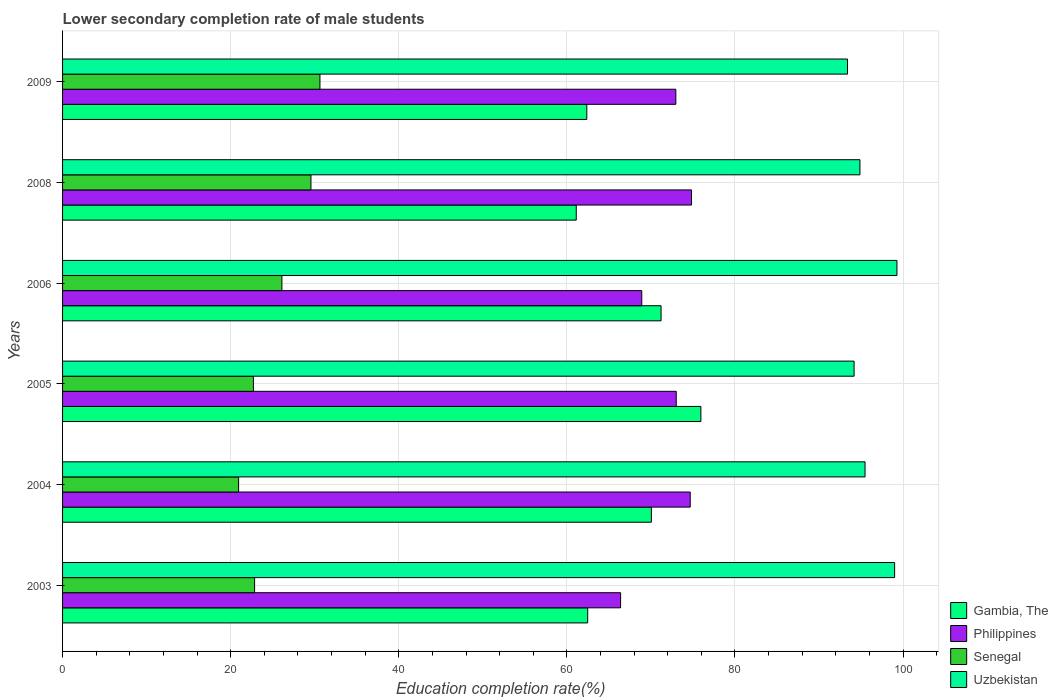How many groups of bars are there?
Give a very brief answer. 6. How many bars are there on the 3rd tick from the top?
Your answer should be very brief. 4. How many bars are there on the 2nd tick from the bottom?
Ensure brevity in your answer.  4. In how many cases, is the number of bars for a given year not equal to the number of legend labels?
Ensure brevity in your answer.  0. What is the lower secondary completion rate of male students in Uzbekistan in 2005?
Offer a very short reply. 94.18. Across all years, what is the maximum lower secondary completion rate of male students in Gambia, The?
Keep it short and to the point. 75.95. Across all years, what is the minimum lower secondary completion rate of male students in Gambia, The?
Provide a succinct answer. 61.12. In which year was the lower secondary completion rate of male students in Gambia, The maximum?
Ensure brevity in your answer.  2005. What is the total lower secondary completion rate of male students in Philippines in the graph?
Provide a succinct answer. 430.8. What is the difference between the lower secondary completion rate of male students in Uzbekistan in 2005 and that in 2006?
Provide a short and direct response. -5.1. What is the difference between the lower secondary completion rate of male students in Philippines in 2004 and the lower secondary completion rate of male students in Uzbekistan in 2009?
Your response must be concise. -18.71. What is the average lower secondary completion rate of male students in Philippines per year?
Provide a succinct answer. 71.8. In the year 2004, what is the difference between the lower secondary completion rate of male students in Senegal and lower secondary completion rate of male students in Gambia, The?
Your response must be concise. -49.11. In how many years, is the lower secondary completion rate of male students in Senegal greater than 32 %?
Your answer should be very brief. 0. What is the ratio of the lower secondary completion rate of male students in Gambia, The in 2003 to that in 2005?
Offer a terse response. 0.82. Is the lower secondary completion rate of male students in Gambia, The in 2004 less than that in 2009?
Ensure brevity in your answer.  No. Is the difference between the lower secondary completion rate of male students in Senegal in 2004 and 2005 greater than the difference between the lower secondary completion rate of male students in Gambia, The in 2004 and 2005?
Provide a short and direct response. Yes. What is the difference between the highest and the second highest lower secondary completion rate of male students in Senegal?
Give a very brief answer. 1.07. What is the difference between the highest and the lowest lower secondary completion rate of male students in Senegal?
Your answer should be compact. 9.68. In how many years, is the lower secondary completion rate of male students in Senegal greater than the average lower secondary completion rate of male students in Senegal taken over all years?
Give a very brief answer. 3. Is it the case that in every year, the sum of the lower secondary completion rate of male students in Senegal and lower secondary completion rate of male students in Uzbekistan is greater than the sum of lower secondary completion rate of male students in Philippines and lower secondary completion rate of male students in Gambia, The?
Provide a succinct answer. No. What does the 1st bar from the top in 2005 represents?
Make the answer very short. Uzbekistan. What does the 4th bar from the bottom in 2006 represents?
Keep it short and to the point. Uzbekistan. Is it the case that in every year, the sum of the lower secondary completion rate of male students in Uzbekistan and lower secondary completion rate of male students in Gambia, The is greater than the lower secondary completion rate of male students in Philippines?
Your answer should be compact. Yes. How many years are there in the graph?
Your answer should be compact. 6. How many legend labels are there?
Provide a short and direct response. 4. What is the title of the graph?
Your answer should be compact. Lower secondary completion rate of male students. What is the label or title of the X-axis?
Offer a terse response. Education completion rate(%). What is the Education completion rate(%) in Gambia, The in 2003?
Your response must be concise. 62.48. What is the Education completion rate(%) in Philippines in 2003?
Keep it short and to the point. 66.39. What is the Education completion rate(%) in Senegal in 2003?
Your answer should be compact. 22.85. What is the Education completion rate(%) in Uzbekistan in 2003?
Offer a terse response. 99. What is the Education completion rate(%) in Gambia, The in 2004?
Offer a very short reply. 70.06. What is the Education completion rate(%) of Philippines in 2004?
Offer a terse response. 74.68. What is the Education completion rate(%) of Senegal in 2004?
Keep it short and to the point. 20.95. What is the Education completion rate(%) of Uzbekistan in 2004?
Ensure brevity in your answer.  95.48. What is the Education completion rate(%) of Gambia, The in 2005?
Provide a succinct answer. 75.95. What is the Education completion rate(%) of Philippines in 2005?
Your response must be concise. 73.02. What is the Education completion rate(%) in Senegal in 2005?
Offer a very short reply. 22.7. What is the Education completion rate(%) in Uzbekistan in 2005?
Give a very brief answer. 94.18. What is the Education completion rate(%) of Gambia, The in 2006?
Your answer should be compact. 71.21. What is the Education completion rate(%) of Philippines in 2006?
Give a very brief answer. 68.91. What is the Education completion rate(%) in Senegal in 2006?
Your answer should be compact. 26.09. What is the Education completion rate(%) of Uzbekistan in 2006?
Provide a succinct answer. 99.27. What is the Education completion rate(%) in Gambia, The in 2008?
Provide a succinct answer. 61.12. What is the Education completion rate(%) of Philippines in 2008?
Provide a succinct answer. 74.83. What is the Education completion rate(%) in Senegal in 2008?
Your answer should be compact. 29.55. What is the Education completion rate(%) of Uzbekistan in 2008?
Your response must be concise. 94.87. What is the Education completion rate(%) in Gambia, The in 2009?
Your answer should be very brief. 62.38. What is the Education completion rate(%) of Philippines in 2009?
Your answer should be compact. 72.97. What is the Education completion rate(%) of Senegal in 2009?
Ensure brevity in your answer.  30.62. What is the Education completion rate(%) in Uzbekistan in 2009?
Your answer should be very brief. 93.39. Across all years, what is the maximum Education completion rate(%) in Gambia, The?
Keep it short and to the point. 75.95. Across all years, what is the maximum Education completion rate(%) in Philippines?
Your answer should be compact. 74.83. Across all years, what is the maximum Education completion rate(%) of Senegal?
Ensure brevity in your answer.  30.62. Across all years, what is the maximum Education completion rate(%) in Uzbekistan?
Offer a very short reply. 99.27. Across all years, what is the minimum Education completion rate(%) in Gambia, The?
Provide a short and direct response. 61.12. Across all years, what is the minimum Education completion rate(%) in Philippines?
Your response must be concise. 66.39. Across all years, what is the minimum Education completion rate(%) of Senegal?
Provide a succinct answer. 20.95. Across all years, what is the minimum Education completion rate(%) in Uzbekistan?
Provide a short and direct response. 93.39. What is the total Education completion rate(%) of Gambia, The in the graph?
Offer a terse response. 403.19. What is the total Education completion rate(%) in Philippines in the graph?
Make the answer very short. 430.8. What is the total Education completion rate(%) in Senegal in the graph?
Make the answer very short. 152.77. What is the total Education completion rate(%) in Uzbekistan in the graph?
Provide a short and direct response. 576.19. What is the difference between the Education completion rate(%) in Gambia, The in 2003 and that in 2004?
Give a very brief answer. -7.58. What is the difference between the Education completion rate(%) in Philippines in 2003 and that in 2004?
Ensure brevity in your answer.  -8.28. What is the difference between the Education completion rate(%) in Senegal in 2003 and that in 2004?
Offer a terse response. 1.9. What is the difference between the Education completion rate(%) in Uzbekistan in 2003 and that in 2004?
Offer a terse response. 3.52. What is the difference between the Education completion rate(%) in Gambia, The in 2003 and that in 2005?
Offer a terse response. -13.47. What is the difference between the Education completion rate(%) of Philippines in 2003 and that in 2005?
Your answer should be very brief. -6.62. What is the difference between the Education completion rate(%) of Senegal in 2003 and that in 2005?
Offer a terse response. 0.14. What is the difference between the Education completion rate(%) in Uzbekistan in 2003 and that in 2005?
Provide a succinct answer. 4.82. What is the difference between the Education completion rate(%) in Gambia, The in 2003 and that in 2006?
Provide a short and direct response. -8.73. What is the difference between the Education completion rate(%) in Philippines in 2003 and that in 2006?
Your answer should be compact. -2.52. What is the difference between the Education completion rate(%) in Senegal in 2003 and that in 2006?
Make the answer very short. -3.25. What is the difference between the Education completion rate(%) of Uzbekistan in 2003 and that in 2006?
Your answer should be very brief. -0.28. What is the difference between the Education completion rate(%) of Gambia, The in 2003 and that in 2008?
Provide a short and direct response. 1.36. What is the difference between the Education completion rate(%) of Philippines in 2003 and that in 2008?
Your answer should be very brief. -8.44. What is the difference between the Education completion rate(%) in Senegal in 2003 and that in 2008?
Give a very brief answer. -6.71. What is the difference between the Education completion rate(%) in Uzbekistan in 2003 and that in 2008?
Offer a very short reply. 4.13. What is the difference between the Education completion rate(%) of Gambia, The in 2003 and that in 2009?
Offer a terse response. 0.1. What is the difference between the Education completion rate(%) of Philippines in 2003 and that in 2009?
Keep it short and to the point. -6.57. What is the difference between the Education completion rate(%) of Senegal in 2003 and that in 2009?
Keep it short and to the point. -7.78. What is the difference between the Education completion rate(%) in Uzbekistan in 2003 and that in 2009?
Your answer should be very brief. 5.61. What is the difference between the Education completion rate(%) in Gambia, The in 2004 and that in 2005?
Offer a terse response. -5.89. What is the difference between the Education completion rate(%) of Philippines in 2004 and that in 2005?
Give a very brief answer. 1.66. What is the difference between the Education completion rate(%) of Senegal in 2004 and that in 2005?
Your response must be concise. -1.76. What is the difference between the Education completion rate(%) of Uzbekistan in 2004 and that in 2005?
Offer a terse response. 1.3. What is the difference between the Education completion rate(%) in Gambia, The in 2004 and that in 2006?
Your answer should be very brief. -1.15. What is the difference between the Education completion rate(%) of Philippines in 2004 and that in 2006?
Your response must be concise. 5.77. What is the difference between the Education completion rate(%) in Senegal in 2004 and that in 2006?
Give a very brief answer. -5.15. What is the difference between the Education completion rate(%) in Uzbekistan in 2004 and that in 2006?
Provide a succinct answer. -3.79. What is the difference between the Education completion rate(%) of Gambia, The in 2004 and that in 2008?
Your response must be concise. 8.94. What is the difference between the Education completion rate(%) in Philippines in 2004 and that in 2008?
Keep it short and to the point. -0.16. What is the difference between the Education completion rate(%) in Senegal in 2004 and that in 2008?
Ensure brevity in your answer.  -8.61. What is the difference between the Education completion rate(%) of Uzbekistan in 2004 and that in 2008?
Provide a succinct answer. 0.61. What is the difference between the Education completion rate(%) in Gambia, The in 2004 and that in 2009?
Your answer should be very brief. 7.68. What is the difference between the Education completion rate(%) in Philippines in 2004 and that in 2009?
Offer a terse response. 1.71. What is the difference between the Education completion rate(%) in Senegal in 2004 and that in 2009?
Your answer should be compact. -9.68. What is the difference between the Education completion rate(%) in Uzbekistan in 2004 and that in 2009?
Offer a terse response. 2.09. What is the difference between the Education completion rate(%) in Gambia, The in 2005 and that in 2006?
Give a very brief answer. 4.74. What is the difference between the Education completion rate(%) of Philippines in 2005 and that in 2006?
Offer a very short reply. 4.1. What is the difference between the Education completion rate(%) in Senegal in 2005 and that in 2006?
Offer a very short reply. -3.39. What is the difference between the Education completion rate(%) of Uzbekistan in 2005 and that in 2006?
Provide a short and direct response. -5.1. What is the difference between the Education completion rate(%) of Gambia, The in 2005 and that in 2008?
Offer a very short reply. 14.83. What is the difference between the Education completion rate(%) in Philippines in 2005 and that in 2008?
Give a very brief answer. -1.82. What is the difference between the Education completion rate(%) in Senegal in 2005 and that in 2008?
Keep it short and to the point. -6.85. What is the difference between the Education completion rate(%) of Uzbekistan in 2005 and that in 2008?
Your answer should be very brief. -0.7. What is the difference between the Education completion rate(%) of Gambia, The in 2005 and that in 2009?
Offer a terse response. 13.57. What is the difference between the Education completion rate(%) in Philippines in 2005 and that in 2009?
Provide a succinct answer. 0.05. What is the difference between the Education completion rate(%) of Senegal in 2005 and that in 2009?
Make the answer very short. -7.92. What is the difference between the Education completion rate(%) of Uzbekistan in 2005 and that in 2009?
Your answer should be compact. 0.78. What is the difference between the Education completion rate(%) in Gambia, The in 2006 and that in 2008?
Give a very brief answer. 10.09. What is the difference between the Education completion rate(%) in Philippines in 2006 and that in 2008?
Make the answer very short. -5.92. What is the difference between the Education completion rate(%) of Senegal in 2006 and that in 2008?
Provide a short and direct response. -3.46. What is the difference between the Education completion rate(%) in Uzbekistan in 2006 and that in 2008?
Give a very brief answer. 4.4. What is the difference between the Education completion rate(%) in Gambia, The in 2006 and that in 2009?
Your response must be concise. 8.83. What is the difference between the Education completion rate(%) of Philippines in 2006 and that in 2009?
Make the answer very short. -4.05. What is the difference between the Education completion rate(%) in Senegal in 2006 and that in 2009?
Provide a succinct answer. -4.53. What is the difference between the Education completion rate(%) of Uzbekistan in 2006 and that in 2009?
Give a very brief answer. 5.88. What is the difference between the Education completion rate(%) in Gambia, The in 2008 and that in 2009?
Offer a very short reply. -1.26. What is the difference between the Education completion rate(%) of Philippines in 2008 and that in 2009?
Keep it short and to the point. 1.87. What is the difference between the Education completion rate(%) in Senegal in 2008 and that in 2009?
Offer a very short reply. -1.07. What is the difference between the Education completion rate(%) of Uzbekistan in 2008 and that in 2009?
Offer a very short reply. 1.48. What is the difference between the Education completion rate(%) in Gambia, The in 2003 and the Education completion rate(%) in Philippines in 2004?
Provide a succinct answer. -12.2. What is the difference between the Education completion rate(%) of Gambia, The in 2003 and the Education completion rate(%) of Senegal in 2004?
Your answer should be very brief. 41.53. What is the difference between the Education completion rate(%) in Gambia, The in 2003 and the Education completion rate(%) in Uzbekistan in 2004?
Your response must be concise. -33. What is the difference between the Education completion rate(%) in Philippines in 2003 and the Education completion rate(%) in Senegal in 2004?
Offer a terse response. 45.45. What is the difference between the Education completion rate(%) in Philippines in 2003 and the Education completion rate(%) in Uzbekistan in 2004?
Your answer should be very brief. -29.09. What is the difference between the Education completion rate(%) of Senegal in 2003 and the Education completion rate(%) of Uzbekistan in 2004?
Your answer should be very brief. -72.63. What is the difference between the Education completion rate(%) of Gambia, The in 2003 and the Education completion rate(%) of Philippines in 2005?
Your answer should be very brief. -10.54. What is the difference between the Education completion rate(%) in Gambia, The in 2003 and the Education completion rate(%) in Senegal in 2005?
Your answer should be compact. 39.77. What is the difference between the Education completion rate(%) of Gambia, The in 2003 and the Education completion rate(%) of Uzbekistan in 2005?
Provide a succinct answer. -31.7. What is the difference between the Education completion rate(%) of Philippines in 2003 and the Education completion rate(%) of Senegal in 2005?
Your answer should be compact. 43.69. What is the difference between the Education completion rate(%) in Philippines in 2003 and the Education completion rate(%) in Uzbekistan in 2005?
Ensure brevity in your answer.  -27.78. What is the difference between the Education completion rate(%) in Senegal in 2003 and the Education completion rate(%) in Uzbekistan in 2005?
Your answer should be very brief. -71.33. What is the difference between the Education completion rate(%) of Gambia, The in 2003 and the Education completion rate(%) of Philippines in 2006?
Provide a succinct answer. -6.43. What is the difference between the Education completion rate(%) of Gambia, The in 2003 and the Education completion rate(%) of Senegal in 2006?
Your answer should be compact. 36.38. What is the difference between the Education completion rate(%) of Gambia, The in 2003 and the Education completion rate(%) of Uzbekistan in 2006?
Provide a succinct answer. -36.8. What is the difference between the Education completion rate(%) in Philippines in 2003 and the Education completion rate(%) in Senegal in 2006?
Your answer should be compact. 40.3. What is the difference between the Education completion rate(%) in Philippines in 2003 and the Education completion rate(%) in Uzbekistan in 2006?
Your answer should be compact. -32.88. What is the difference between the Education completion rate(%) of Senegal in 2003 and the Education completion rate(%) of Uzbekistan in 2006?
Your response must be concise. -76.43. What is the difference between the Education completion rate(%) in Gambia, The in 2003 and the Education completion rate(%) in Philippines in 2008?
Keep it short and to the point. -12.36. What is the difference between the Education completion rate(%) in Gambia, The in 2003 and the Education completion rate(%) in Senegal in 2008?
Offer a terse response. 32.93. What is the difference between the Education completion rate(%) of Gambia, The in 2003 and the Education completion rate(%) of Uzbekistan in 2008?
Provide a succinct answer. -32.39. What is the difference between the Education completion rate(%) in Philippines in 2003 and the Education completion rate(%) in Senegal in 2008?
Make the answer very short. 36.84. What is the difference between the Education completion rate(%) of Philippines in 2003 and the Education completion rate(%) of Uzbekistan in 2008?
Offer a very short reply. -28.48. What is the difference between the Education completion rate(%) in Senegal in 2003 and the Education completion rate(%) in Uzbekistan in 2008?
Give a very brief answer. -72.02. What is the difference between the Education completion rate(%) of Gambia, The in 2003 and the Education completion rate(%) of Philippines in 2009?
Make the answer very short. -10.49. What is the difference between the Education completion rate(%) of Gambia, The in 2003 and the Education completion rate(%) of Senegal in 2009?
Offer a terse response. 31.86. What is the difference between the Education completion rate(%) in Gambia, The in 2003 and the Education completion rate(%) in Uzbekistan in 2009?
Offer a very short reply. -30.91. What is the difference between the Education completion rate(%) in Philippines in 2003 and the Education completion rate(%) in Senegal in 2009?
Give a very brief answer. 35.77. What is the difference between the Education completion rate(%) of Philippines in 2003 and the Education completion rate(%) of Uzbekistan in 2009?
Make the answer very short. -27. What is the difference between the Education completion rate(%) of Senegal in 2003 and the Education completion rate(%) of Uzbekistan in 2009?
Offer a very short reply. -70.55. What is the difference between the Education completion rate(%) of Gambia, The in 2004 and the Education completion rate(%) of Philippines in 2005?
Make the answer very short. -2.96. What is the difference between the Education completion rate(%) of Gambia, The in 2004 and the Education completion rate(%) of Senegal in 2005?
Your answer should be compact. 47.35. What is the difference between the Education completion rate(%) of Gambia, The in 2004 and the Education completion rate(%) of Uzbekistan in 2005?
Your answer should be very brief. -24.12. What is the difference between the Education completion rate(%) in Philippines in 2004 and the Education completion rate(%) in Senegal in 2005?
Provide a succinct answer. 51.97. What is the difference between the Education completion rate(%) in Philippines in 2004 and the Education completion rate(%) in Uzbekistan in 2005?
Give a very brief answer. -19.5. What is the difference between the Education completion rate(%) in Senegal in 2004 and the Education completion rate(%) in Uzbekistan in 2005?
Your answer should be very brief. -73.23. What is the difference between the Education completion rate(%) of Gambia, The in 2004 and the Education completion rate(%) of Philippines in 2006?
Make the answer very short. 1.14. What is the difference between the Education completion rate(%) of Gambia, The in 2004 and the Education completion rate(%) of Senegal in 2006?
Give a very brief answer. 43.96. What is the difference between the Education completion rate(%) of Gambia, The in 2004 and the Education completion rate(%) of Uzbekistan in 2006?
Keep it short and to the point. -29.22. What is the difference between the Education completion rate(%) of Philippines in 2004 and the Education completion rate(%) of Senegal in 2006?
Give a very brief answer. 48.58. What is the difference between the Education completion rate(%) in Philippines in 2004 and the Education completion rate(%) in Uzbekistan in 2006?
Your answer should be compact. -24.6. What is the difference between the Education completion rate(%) in Senegal in 2004 and the Education completion rate(%) in Uzbekistan in 2006?
Offer a terse response. -78.33. What is the difference between the Education completion rate(%) in Gambia, The in 2004 and the Education completion rate(%) in Philippines in 2008?
Provide a succinct answer. -4.78. What is the difference between the Education completion rate(%) of Gambia, The in 2004 and the Education completion rate(%) of Senegal in 2008?
Give a very brief answer. 40.5. What is the difference between the Education completion rate(%) of Gambia, The in 2004 and the Education completion rate(%) of Uzbekistan in 2008?
Your answer should be very brief. -24.81. What is the difference between the Education completion rate(%) of Philippines in 2004 and the Education completion rate(%) of Senegal in 2008?
Your answer should be compact. 45.13. What is the difference between the Education completion rate(%) of Philippines in 2004 and the Education completion rate(%) of Uzbekistan in 2008?
Your answer should be compact. -20.19. What is the difference between the Education completion rate(%) in Senegal in 2004 and the Education completion rate(%) in Uzbekistan in 2008?
Your response must be concise. -73.92. What is the difference between the Education completion rate(%) of Gambia, The in 2004 and the Education completion rate(%) of Philippines in 2009?
Your answer should be compact. -2.91. What is the difference between the Education completion rate(%) in Gambia, The in 2004 and the Education completion rate(%) in Senegal in 2009?
Provide a succinct answer. 39.43. What is the difference between the Education completion rate(%) of Gambia, The in 2004 and the Education completion rate(%) of Uzbekistan in 2009?
Provide a succinct answer. -23.34. What is the difference between the Education completion rate(%) of Philippines in 2004 and the Education completion rate(%) of Senegal in 2009?
Ensure brevity in your answer.  44.06. What is the difference between the Education completion rate(%) of Philippines in 2004 and the Education completion rate(%) of Uzbekistan in 2009?
Your answer should be compact. -18.71. What is the difference between the Education completion rate(%) in Senegal in 2004 and the Education completion rate(%) in Uzbekistan in 2009?
Keep it short and to the point. -72.45. What is the difference between the Education completion rate(%) in Gambia, The in 2005 and the Education completion rate(%) in Philippines in 2006?
Offer a terse response. 7.03. What is the difference between the Education completion rate(%) in Gambia, The in 2005 and the Education completion rate(%) in Senegal in 2006?
Keep it short and to the point. 49.85. What is the difference between the Education completion rate(%) of Gambia, The in 2005 and the Education completion rate(%) of Uzbekistan in 2006?
Make the answer very short. -23.33. What is the difference between the Education completion rate(%) of Philippines in 2005 and the Education completion rate(%) of Senegal in 2006?
Provide a succinct answer. 46.92. What is the difference between the Education completion rate(%) in Philippines in 2005 and the Education completion rate(%) in Uzbekistan in 2006?
Make the answer very short. -26.26. What is the difference between the Education completion rate(%) in Senegal in 2005 and the Education completion rate(%) in Uzbekistan in 2006?
Offer a terse response. -76.57. What is the difference between the Education completion rate(%) of Gambia, The in 2005 and the Education completion rate(%) of Philippines in 2008?
Give a very brief answer. 1.11. What is the difference between the Education completion rate(%) of Gambia, The in 2005 and the Education completion rate(%) of Senegal in 2008?
Your answer should be compact. 46.39. What is the difference between the Education completion rate(%) in Gambia, The in 2005 and the Education completion rate(%) in Uzbekistan in 2008?
Offer a terse response. -18.92. What is the difference between the Education completion rate(%) in Philippines in 2005 and the Education completion rate(%) in Senegal in 2008?
Ensure brevity in your answer.  43.46. What is the difference between the Education completion rate(%) of Philippines in 2005 and the Education completion rate(%) of Uzbekistan in 2008?
Provide a short and direct response. -21.85. What is the difference between the Education completion rate(%) in Senegal in 2005 and the Education completion rate(%) in Uzbekistan in 2008?
Your response must be concise. -72.17. What is the difference between the Education completion rate(%) in Gambia, The in 2005 and the Education completion rate(%) in Philippines in 2009?
Offer a terse response. 2.98. What is the difference between the Education completion rate(%) in Gambia, The in 2005 and the Education completion rate(%) in Senegal in 2009?
Offer a very short reply. 45.32. What is the difference between the Education completion rate(%) of Gambia, The in 2005 and the Education completion rate(%) of Uzbekistan in 2009?
Provide a short and direct response. -17.45. What is the difference between the Education completion rate(%) in Philippines in 2005 and the Education completion rate(%) in Senegal in 2009?
Ensure brevity in your answer.  42.39. What is the difference between the Education completion rate(%) in Philippines in 2005 and the Education completion rate(%) in Uzbekistan in 2009?
Make the answer very short. -20.38. What is the difference between the Education completion rate(%) of Senegal in 2005 and the Education completion rate(%) of Uzbekistan in 2009?
Provide a succinct answer. -70.69. What is the difference between the Education completion rate(%) in Gambia, The in 2006 and the Education completion rate(%) in Philippines in 2008?
Offer a terse response. -3.63. What is the difference between the Education completion rate(%) of Gambia, The in 2006 and the Education completion rate(%) of Senegal in 2008?
Provide a short and direct response. 41.66. What is the difference between the Education completion rate(%) in Gambia, The in 2006 and the Education completion rate(%) in Uzbekistan in 2008?
Provide a succinct answer. -23.66. What is the difference between the Education completion rate(%) in Philippines in 2006 and the Education completion rate(%) in Senegal in 2008?
Make the answer very short. 39.36. What is the difference between the Education completion rate(%) in Philippines in 2006 and the Education completion rate(%) in Uzbekistan in 2008?
Make the answer very short. -25.96. What is the difference between the Education completion rate(%) in Senegal in 2006 and the Education completion rate(%) in Uzbekistan in 2008?
Give a very brief answer. -68.78. What is the difference between the Education completion rate(%) in Gambia, The in 2006 and the Education completion rate(%) in Philippines in 2009?
Provide a short and direct response. -1.76. What is the difference between the Education completion rate(%) in Gambia, The in 2006 and the Education completion rate(%) in Senegal in 2009?
Your answer should be compact. 40.59. What is the difference between the Education completion rate(%) of Gambia, The in 2006 and the Education completion rate(%) of Uzbekistan in 2009?
Offer a terse response. -22.18. What is the difference between the Education completion rate(%) of Philippines in 2006 and the Education completion rate(%) of Senegal in 2009?
Offer a very short reply. 38.29. What is the difference between the Education completion rate(%) in Philippines in 2006 and the Education completion rate(%) in Uzbekistan in 2009?
Provide a short and direct response. -24.48. What is the difference between the Education completion rate(%) in Senegal in 2006 and the Education completion rate(%) in Uzbekistan in 2009?
Give a very brief answer. -67.3. What is the difference between the Education completion rate(%) in Gambia, The in 2008 and the Education completion rate(%) in Philippines in 2009?
Provide a short and direct response. -11.85. What is the difference between the Education completion rate(%) of Gambia, The in 2008 and the Education completion rate(%) of Senegal in 2009?
Your answer should be very brief. 30.49. What is the difference between the Education completion rate(%) of Gambia, The in 2008 and the Education completion rate(%) of Uzbekistan in 2009?
Ensure brevity in your answer.  -32.27. What is the difference between the Education completion rate(%) in Philippines in 2008 and the Education completion rate(%) in Senegal in 2009?
Provide a short and direct response. 44.21. What is the difference between the Education completion rate(%) of Philippines in 2008 and the Education completion rate(%) of Uzbekistan in 2009?
Offer a terse response. -18.56. What is the difference between the Education completion rate(%) of Senegal in 2008 and the Education completion rate(%) of Uzbekistan in 2009?
Your answer should be compact. -63.84. What is the average Education completion rate(%) of Gambia, The per year?
Your answer should be very brief. 67.2. What is the average Education completion rate(%) in Philippines per year?
Your response must be concise. 71.8. What is the average Education completion rate(%) in Senegal per year?
Your answer should be very brief. 25.46. What is the average Education completion rate(%) in Uzbekistan per year?
Offer a terse response. 96.03. In the year 2003, what is the difference between the Education completion rate(%) in Gambia, The and Education completion rate(%) in Philippines?
Keep it short and to the point. -3.92. In the year 2003, what is the difference between the Education completion rate(%) in Gambia, The and Education completion rate(%) in Senegal?
Keep it short and to the point. 39.63. In the year 2003, what is the difference between the Education completion rate(%) in Gambia, The and Education completion rate(%) in Uzbekistan?
Your response must be concise. -36.52. In the year 2003, what is the difference between the Education completion rate(%) of Philippines and Education completion rate(%) of Senegal?
Offer a terse response. 43.55. In the year 2003, what is the difference between the Education completion rate(%) of Philippines and Education completion rate(%) of Uzbekistan?
Provide a succinct answer. -32.6. In the year 2003, what is the difference between the Education completion rate(%) of Senegal and Education completion rate(%) of Uzbekistan?
Your answer should be compact. -76.15. In the year 2004, what is the difference between the Education completion rate(%) of Gambia, The and Education completion rate(%) of Philippines?
Provide a short and direct response. -4.62. In the year 2004, what is the difference between the Education completion rate(%) in Gambia, The and Education completion rate(%) in Senegal?
Offer a terse response. 49.11. In the year 2004, what is the difference between the Education completion rate(%) of Gambia, The and Education completion rate(%) of Uzbekistan?
Your response must be concise. -25.42. In the year 2004, what is the difference between the Education completion rate(%) of Philippines and Education completion rate(%) of Senegal?
Give a very brief answer. 53.73. In the year 2004, what is the difference between the Education completion rate(%) in Philippines and Education completion rate(%) in Uzbekistan?
Your response must be concise. -20.8. In the year 2004, what is the difference between the Education completion rate(%) of Senegal and Education completion rate(%) of Uzbekistan?
Give a very brief answer. -74.53. In the year 2005, what is the difference between the Education completion rate(%) in Gambia, The and Education completion rate(%) in Philippines?
Provide a short and direct response. 2.93. In the year 2005, what is the difference between the Education completion rate(%) in Gambia, The and Education completion rate(%) in Senegal?
Make the answer very short. 53.24. In the year 2005, what is the difference between the Education completion rate(%) in Gambia, The and Education completion rate(%) in Uzbekistan?
Provide a short and direct response. -18.23. In the year 2005, what is the difference between the Education completion rate(%) in Philippines and Education completion rate(%) in Senegal?
Offer a terse response. 50.31. In the year 2005, what is the difference between the Education completion rate(%) in Philippines and Education completion rate(%) in Uzbekistan?
Your response must be concise. -21.16. In the year 2005, what is the difference between the Education completion rate(%) in Senegal and Education completion rate(%) in Uzbekistan?
Offer a terse response. -71.47. In the year 2006, what is the difference between the Education completion rate(%) of Gambia, The and Education completion rate(%) of Philippines?
Provide a succinct answer. 2.3. In the year 2006, what is the difference between the Education completion rate(%) of Gambia, The and Education completion rate(%) of Senegal?
Make the answer very short. 45.11. In the year 2006, what is the difference between the Education completion rate(%) of Gambia, The and Education completion rate(%) of Uzbekistan?
Provide a succinct answer. -28.07. In the year 2006, what is the difference between the Education completion rate(%) in Philippines and Education completion rate(%) in Senegal?
Offer a terse response. 42.82. In the year 2006, what is the difference between the Education completion rate(%) in Philippines and Education completion rate(%) in Uzbekistan?
Your answer should be compact. -30.36. In the year 2006, what is the difference between the Education completion rate(%) in Senegal and Education completion rate(%) in Uzbekistan?
Provide a succinct answer. -73.18. In the year 2008, what is the difference between the Education completion rate(%) in Gambia, The and Education completion rate(%) in Philippines?
Offer a terse response. -13.72. In the year 2008, what is the difference between the Education completion rate(%) of Gambia, The and Education completion rate(%) of Senegal?
Ensure brevity in your answer.  31.56. In the year 2008, what is the difference between the Education completion rate(%) of Gambia, The and Education completion rate(%) of Uzbekistan?
Make the answer very short. -33.75. In the year 2008, what is the difference between the Education completion rate(%) in Philippines and Education completion rate(%) in Senegal?
Provide a short and direct response. 45.28. In the year 2008, what is the difference between the Education completion rate(%) in Philippines and Education completion rate(%) in Uzbekistan?
Make the answer very short. -20.04. In the year 2008, what is the difference between the Education completion rate(%) of Senegal and Education completion rate(%) of Uzbekistan?
Your response must be concise. -65.32. In the year 2009, what is the difference between the Education completion rate(%) of Gambia, The and Education completion rate(%) of Philippines?
Keep it short and to the point. -10.59. In the year 2009, what is the difference between the Education completion rate(%) of Gambia, The and Education completion rate(%) of Senegal?
Your answer should be very brief. 31.75. In the year 2009, what is the difference between the Education completion rate(%) of Gambia, The and Education completion rate(%) of Uzbekistan?
Ensure brevity in your answer.  -31.02. In the year 2009, what is the difference between the Education completion rate(%) in Philippines and Education completion rate(%) in Senegal?
Offer a terse response. 42.34. In the year 2009, what is the difference between the Education completion rate(%) of Philippines and Education completion rate(%) of Uzbekistan?
Make the answer very short. -20.43. In the year 2009, what is the difference between the Education completion rate(%) of Senegal and Education completion rate(%) of Uzbekistan?
Ensure brevity in your answer.  -62.77. What is the ratio of the Education completion rate(%) in Gambia, The in 2003 to that in 2004?
Offer a very short reply. 0.89. What is the ratio of the Education completion rate(%) in Philippines in 2003 to that in 2004?
Offer a terse response. 0.89. What is the ratio of the Education completion rate(%) of Senegal in 2003 to that in 2004?
Make the answer very short. 1.09. What is the ratio of the Education completion rate(%) in Uzbekistan in 2003 to that in 2004?
Your response must be concise. 1.04. What is the ratio of the Education completion rate(%) in Gambia, The in 2003 to that in 2005?
Provide a short and direct response. 0.82. What is the ratio of the Education completion rate(%) of Philippines in 2003 to that in 2005?
Your answer should be compact. 0.91. What is the ratio of the Education completion rate(%) of Uzbekistan in 2003 to that in 2005?
Offer a terse response. 1.05. What is the ratio of the Education completion rate(%) of Gambia, The in 2003 to that in 2006?
Provide a short and direct response. 0.88. What is the ratio of the Education completion rate(%) of Philippines in 2003 to that in 2006?
Your answer should be very brief. 0.96. What is the ratio of the Education completion rate(%) of Senegal in 2003 to that in 2006?
Give a very brief answer. 0.88. What is the ratio of the Education completion rate(%) of Gambia, The in 2003 to that in 2008?
Keep it short and to the point. 1.02. What is the ratio of the Education completion rate(%) in Philippines in 2003 to that in 2008?
Keep it short and to the point. 0.89. What is the ratio of the Education completion rate(%) of Senegal in 2003 to that in 2008?
Your answer should be compact. 0.77. What is the ratio of the Education completion rate(%) in Uzbekistan in 2003 to that in 2008?
Ensure brevity in your answer.  1.04. What is the ratio of the Education completion rate(%) of Gambia, The in 2003 to that in 2009?
Your answer should be very brief. 1. What is the ratio of the Education completion rate(%) in Philippines in 2003 to that in 2009?
Offer a terse response. 0.91. What is the ratio of the Education completion rate(%) of Senegal in 2003 to that in 2009?
Offer a very short reply. 0.75. What is the ratio of the Education completion rate(%) of Uzbekistan in 2003 to that in 2009?
Your answer should be compact. 1.06. What is the ratio of the Education completion rate(%) of Gambia, The in 2004 to that in 2005?
Your answer should be compact. 0.92. What is the ratio of the Education completion rate(%) in Philippines in 2004 to that in 2005?
Your answer should be very brief. 1.02. What is the ratio of the Education completion rate(%) of Senegal in 2004 to that in 2005?
Give a very brief answer. 0.92. What is the ratio of the Education completion rate(%) of Uzbekistan in 2004 to that in 2005?
Keep it short and to the point. 1.01. What is the ratio of the Education completion rate(%) of Gambia, The in 2004 to that in 2006?
Provide a succinct answer. 0.98. What is the ratio of the Education completion rate(%) of Philippines in 2004 to that in 2006?
Offer a very short reply. 1.08. What is the ratio of the Education completion rate(%) of Senegal in 2004 to that in 2006?
Give a very brief answer. 0.8. What is the ratio of the Education completion rate(%) in Uzbekistan in 2004 to that in 2006?
Your response must be concise. 0.96. What is the ratio of the Education completion rate(%) of Gambia, The in 2004 to that in 2008?
Provide a short and direct response. 1.15. What is the ratio of the Education completion rate(%) in Senegal in 2004 to that in 2008?
Ensure brevity in your answer.  0.71. What is the ratio of the Education completion rate(%) of Uzbekistan in 2004 to that in 2008?
Provide a succinct answer. 1.01. What is the ratio of the Education completion rate(%) in Gambia, The in 2004 to that in 2009?
Keep it short and to the point. 1.12. What is the ratio of the Education completion rate(%) in Philippines in 2004 to that in 2009?
Your response must be concise. 1.02. What is the ratio of the Education completion rate(%) in Senegal in 2004 to that in 2009?
Offer a terse response. 0.68. What is the ratio of the Education completion rate(%) in Uzbekistan in 2004 to that in 2009?
Ensure brevity in your answer.  1.02. What is the ratio of the Education completion rate(%) in Gambia, The in 2005 to that in 2006?
Make the answer very short. 1.07. What is the ratio of the Education completion rate(%) of Philippines in 2005 to that in 2006?
Offer a terse response. 1.06. What is the ratio of the Education completion rate(%) in Senegal in 2005 to that in 2006?
Offer a terse response. 0.87. What is the ratio of the Education completion rate(%) in Uzbekistan in 2005 to that in 2006?
Make the answer very short. 0.95. What is the ratio of the Education completion rate(%) of Gambia, The in 2005 to that in 2008?
Your answer should be very brief. 1.24. What is the ratio of the Education completion rate(%) of Philippines in 2005 to that in 2008?
Your answer should be very brief. 0.98. What is the ratio of the Education completion rate(%) of Senegal in 2005 to that in 2008?
Your response must be concise. 0.77. What is the ratio of the Education completion rate(%) in Uzbekistan in 2005 to that in 2008?
Your answer should be compact. 0.99. What is the ratio of the Education completion rate(%) in Gambia, The in 2005 to that in 2009?
Make the answer very short. 1.22. What is the ratio of the Education completion rate(%) in Philippines in 2005 to that in 2009?
Offer a very short reply. 1. What is the ratio of the Education completion rate(%) of Senegal in 2005 to that in 2009?
Your response must be concise. 0.74. What is the ratio of the Education completion rate(%) of Uzbekistan in 2005 to that in 2009?
Offer a very short reply. 1.01. What is the ratio of the Education completion rate(%) of Gambia, The in 2006 to that in 2008?
Offer a very short reply. 1.17. What is the ratio of the Education completion rate(%) of Philippines in 2006 to that in 2008?
Your response must be concise. 0.92. What is the ratio of the Education completion rate(%) in Senegal in 2006 to that in 2008?
Your response must be concise. 0.88. What is the ratio of the Education completion rate(%) in Uzbekistan in 2006 to that in 2008?
Give a very brief answer. 1.05. What is the ratio of the Education completion rate(%) in Gambia, The in 2006 to that in 2009?
Make the answer very short. 1.14. What is the ratio of the Education completion rate(%) of Philippines in 2006 to that in 2009?
Offer a terse response. 0.94. What is the ratio of the Education completion rate(%) in Senegal in 2006 to that in 2009?
Your answer should be very brief. 0.85. What is the ratio of the Education completion rate(%) of Uzbekistan in 2006 to that in 2009?
Your response must be concise. 1.06. What is the ratio of the Education completion rate(%) of Gambia, The in 2008 to that in 2009?
Give a very brief answer. 0.98. What is the ratio of the Education completion rate(%) of Philippines in 2008 to that in 2009?
Your answer should be compact. 1.03. What is the ratio of the Education completion rate(%) in Senegal in 2008 to that in 2009?
Offer a terse response. 0.97. What is the ratio of the Education completion rate(%) of Uzbekistan in 2008 to that in 2009?
Provide a succinct answer. 1.02. What is the difference between the highest and the second highest Education completion rate(%) in Gambia, The?
Offer a terse response. 4.74. What is the difference between the highest and the second highest Education completion rate(%) in Philippines?
Provide a succinct answer. 0.16. What is the difference between the highest and the second highest Education completion rate(%) of Senegal?
Your answer should be compact. 1.07. What is the difference between the highest and the second highest Education completion rate(%) of Uzbekistan?
Your response must be concise. 0.28. What is the difference between the highest and the lowest Education completion rate(%) of Gambia, The?
Offer a terse response. 14.83. What is the difference between the highest and the lowest Education completion rate(%) of Philippines?
Ensure brevity in your answer.  8.44. What is the difference between the highest and the lowest Education completion rate(%) in Senegal?
Offer a terse response. 9.68. What is the difference between the highest and the lowest Education completion rate(%) in Uzbekistan?
Your answer should be compact. 5.88. 